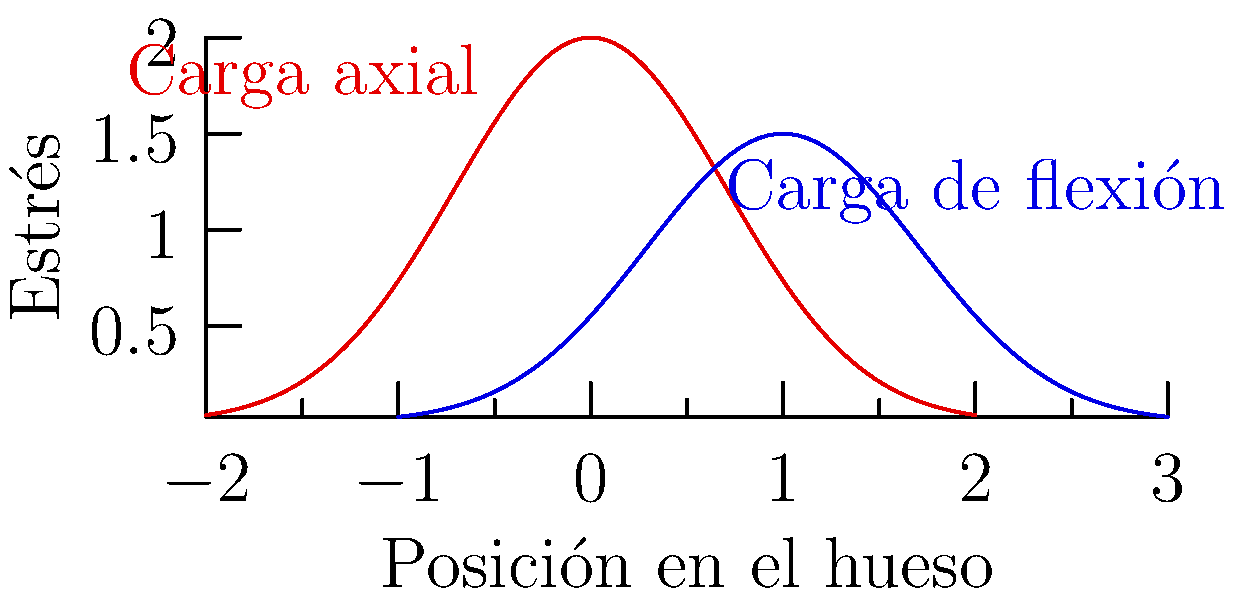Analice el gráfico que muestra la distribución de estrés en un hueso largo bajo dos condiciones de carga diferentes: carga axial (rojo) y carga de flexión (azul). ¿Cuál es la principal diferencia en la distribución del estrés entre estas dos condiciones de carga y qué implicaciones tiene esto para la resistencia del hueso? Para analizar la diferencia en la distribución del estrés, sigamos estos pasos:

1. Carga axial (curva roja):
   - La distribución es simétrica alrededor del centro del hueso.
   - El estrés máximo se encuentra en el centro y disminuye hacia los extremos.
   - La ecuación que representa esta distribución es aproximadamente $f(x) = 2e^{-x^2}$.

2. Carga de flexión (curva azul):
   - La distribución es asimétrica.
   - El estrés máximo está desplazado hacia un lado del hueso.
   - La ecuación que representa esta distribución es aproximadamente $g(x) = 1.5e^{-(x-1)^2}$.

3. Comparación de las distribuciones:
   - La carga axial distribuye el estrés más uniformemente a lo largo del hueso.
   - La carga de flexión concentra el estrés en una región específica.

4. Implicaciones para la resistencia del hueso:
   - En la carga axial, el hueso soporta el estrés de manera más uniforme, lo que puede ser beneficioso para su resistencia general.
   - En la carga de flexión, la concentración de estrés en un área específica puede hacer que el hueso sea más susceptible a fracturas en ese punto.

5. Adaptación del hueso:
   - Los huesos se adaptan a las cargas habituales mediante el remodelado óseo.
   - La distribución de estrés influye en dónde el hueso añade o remueve material para optimizar su resistencia.
Answer: La carga axial distribuye el estrés uniformemente, mientras que la carga de flexión lo concentra en un área específica, lo que puede aumentar el riesgo de fractura en ese punto. 